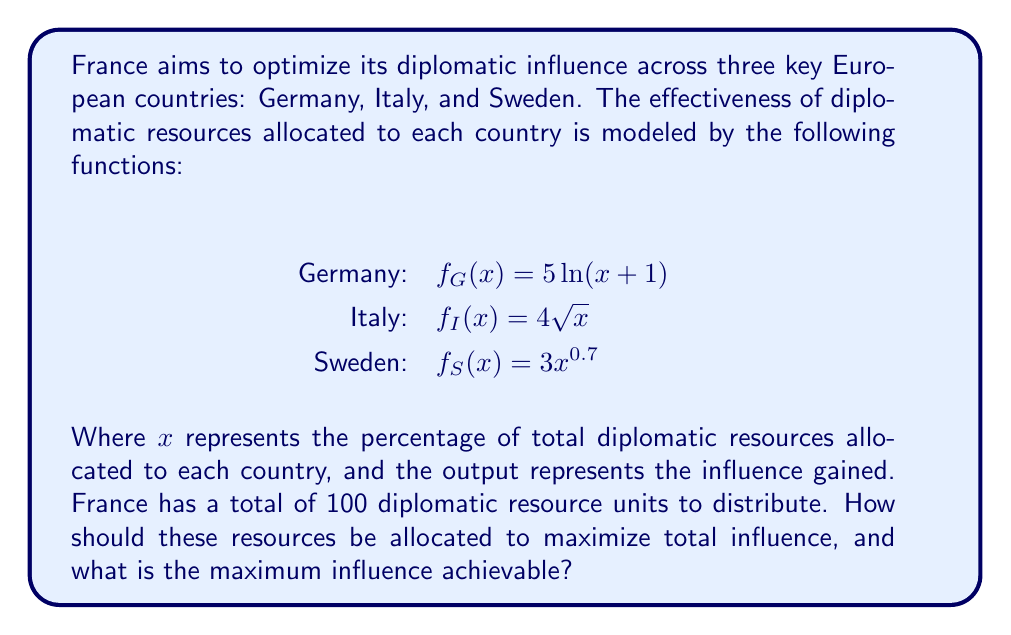Can you answer this question? To solve this problem, we'll use the method of Lagrange multipliers:

1) Let $x$, $y$, and $z$ be the percentages allocated to Germany, Italy, and Sweden respectively.

2) Our objective function is:
   $F(x,y,z) = 5\ln(x+1) + 4\sqrt{y} + 3z^{0.7}$

3) The constraint is:
   $g(x,y,z) = x + y + z - 100 = 0$

4) Form the Lagrangian:
   $L(x,y,z,\lambda) = 5\ln(x+1) + 4\sqrt{y} + 3z^{0.7} - \lambda(x + y + z - 100)$

5) Take partial derivatives and set them to zero:
   $\frac{\partial L}{\partial x} = \frac{5}{x+1} - \lambda = 0$
   $\frac{\partial L}{\partial y} = \frac{2}{\sqrt{y}} - \lambda = 0$
   $\frac{\partial L}{\partial z} = \frac{2.1}{z^{0.3}} - \lambda = 0$
   $\frac{\partial L}{\partial \lambda} = x + y + z - 100 = 0$

6) From these equations:
   $x + 1 = \frac{5}{\lambda}$
   $y = \frac{4}{\lambda^2}$
   $z = (\frac{2.1}{\lambda})^{\frac{10}{3}}$

7) Substitute these into the constraint equation:
   $\frac{5}{\lambda} - 1 + \frac{4}{\lambda^2} + (\frac{2.1}{\lambda})^{\frac{10}{3}} = 100$

8) Solve this equation numerically to get $\lambda \approx 0.0978$

9) Substitute this value back to get:
   $x \approx 50.13$
   $y \approx 41.89$
   $z \approx 7.98$

10) The maximum influence is:
    $F(50.13, 41.89, 7.98) \approx 39.56$
Answer: Allocate 50.13% to Germany, 41.89% to Italy, 7.98% to Sweden. Maximum influence: 39.56. 